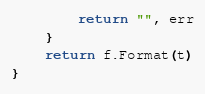Convert code to text. <code><loc_0><loc_0><loc_500><loc_500><_Go_>		return "", err
	}
	return f.Format(t)
}
</code> 